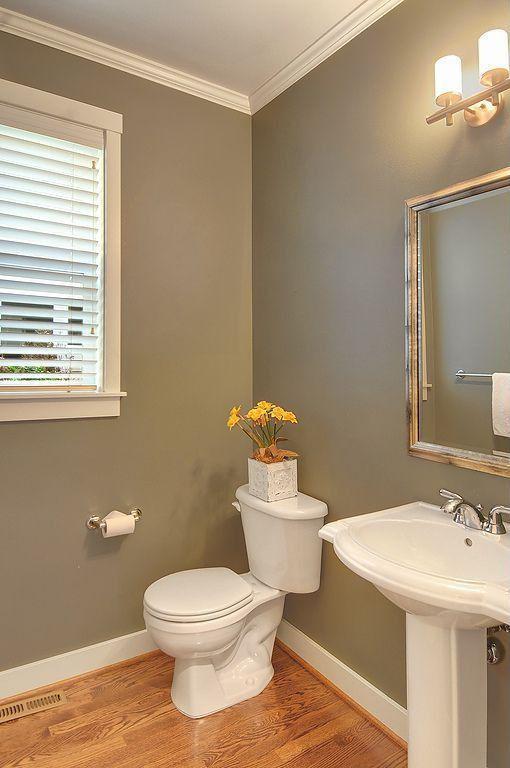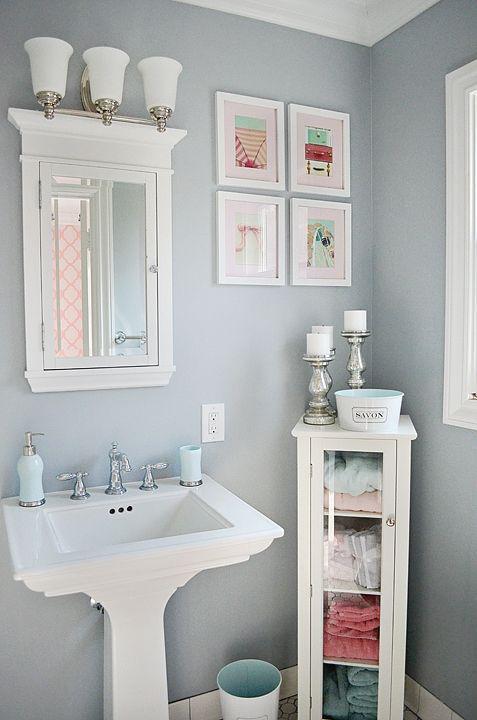The first image is the image on the left, the second image is the image on the right. Assess this claim about the two images: "One bathroom features a rectangular mirror over a pedestal sink with a flower in a vase on it, and the other image shows a sink with a box-shaped vanity and a non-square mirror.". Correct or not? Answer yes or no. No. The first image is the image on the left, the second image is the image on the right. Evaluate the accuracy of this statement regarding the images: "One of the images features a sink with a cabinet underneath.". Is it true? Answer yes or no. No. 